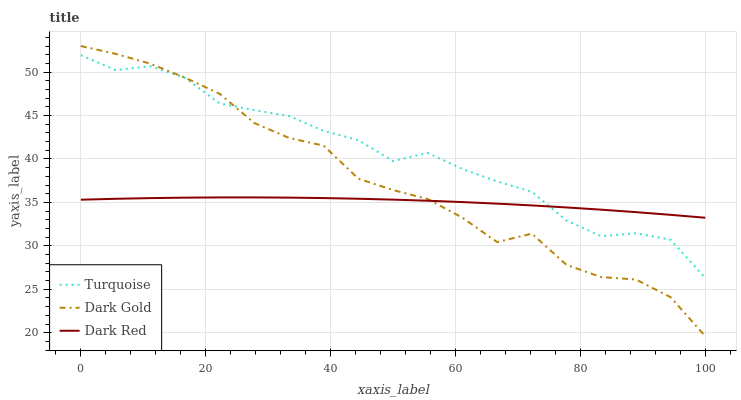Does Dark Red have the minimum area under the curve?
Answer yes or no. Yes. Does Dark Gold have the minimum area under the curve?
Answer yes or no. No. Does Dark Gold have the maximum area under the curve?
Answer yes or no. No. Is Turquoise the smoothest?
Answer yes or no. No. Is Turquoise the roughest?
Answer yes or no. No. Does Turquoise have the lowest value?
Answer yes or no. No. Does Turquoise have the highest value?
Answer yes or no. No. 